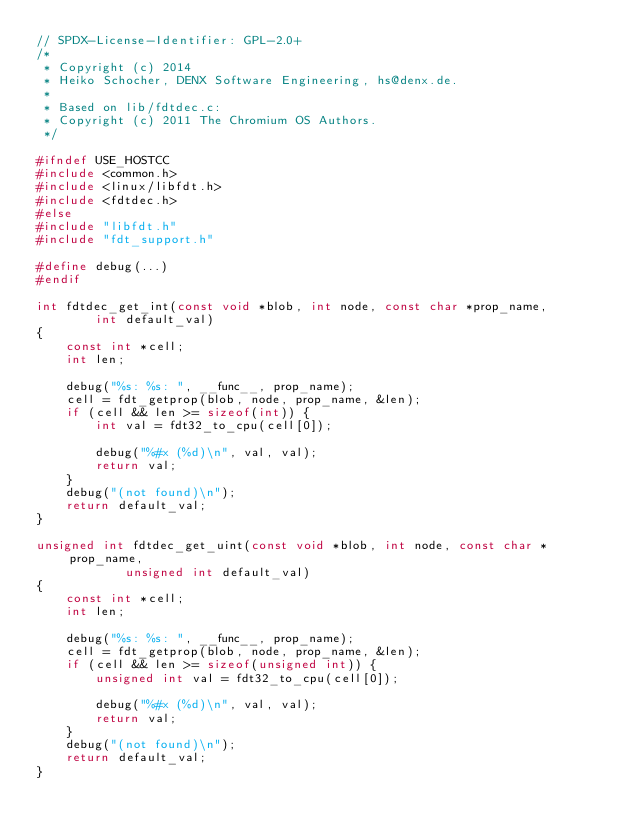Convert code to text. <code><loc_0><loc_0><loc_500><loc_500><_C_>// SPDX-License-Identifier: GPL-2.0+
/*
 * Copyright (c) 2014
 * Heiko Schocher, DENX Software Engineering, hs@denx.de.
 *
 * Based on lib/fdtdec.c:
 * Copyright (c) 2011 The Chromium OS Authors.
 */

#ifndef USE_HOSTCC
#include <common.h>
#include <linux/libfdt.h>
#include <fdtdec.h>
#else
#include "libfdt.h"
#include "fdt_support.h"

#define debug(...)
#endif

int fdtdec_get_int(const void *blob, int node, const char *prop_name,
		int default_val)
{
	const int *cell;
	int len;

	debug("%s: %s: ", __func__, prop_name);
	cell = fdt_getprop(blob, node, prop_name, &len);
	if (cell && len >= sizeof(int)) {
		int val = fdt32_to_cpu(cell[0]);

		debug("%#x (%d)\n", val, val);
		return val;
	}
	debug("(not found)\n");
	return default_val;
}

unsigned int fdtdec_get_uint(const void *blob, int node, const char *prop_name,
			unsigned int default_val)
{
	const int *cell;
	int len;

	debug("%s: %s: ", __func__, prop_name);
	cell = fdt_getprop(blob, node, prop_name, &len);
	if (cell && len >= sizeof(unsigned int)) {
		unsigned int val = fdt32_to_cpu(cell[0]);

		debug("%#x (%d)\n", val, val);
		return val;
	}
	debug("(not found)\n");
	return default_val;
}
</code> 